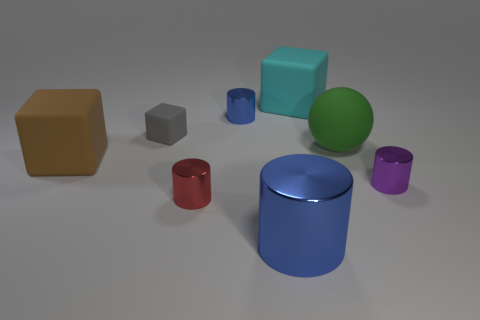How many other things are there of the same size as the purple metallic cylinder?
Keep it short and to the point. 3. What number of large things are either gray matte things or green matte balls?
Provide a succinct answer. 1. Is the size of the brown matte cube the same as the blue cylinder in front of the small gray rubber thing?
Offer a very short reply. Yes. How many other objects are there of the same shape as the tiny purple object?
Ensure brevity in your answer.  3. There is a tiny gray object that is the same material as the sphere; what shape is it?
Provide a short and direct response. Cube. Are there any small purple matte cylinders?
Provide a short and direct response. No. Is the number of rubber spheres that are on the right side of the purple cylinder less than the number of blue objects that are behind the matte ball?
Your response must be concise. Yes. What is the shape of the purple shiny object that is behind the small red shiny cylinder?
Offer a terse response. Cylinder. Do the big blue cylinder and the big green thing have the same material?
Provide a succinct answer. No. There is a small gray object that is the same shape as the large cyan rubber object; what is its material?
Offer a terse response. Rubber. 